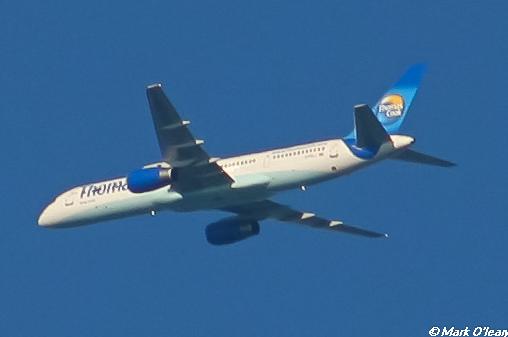How big plane is this?
Quick response, please. Large. What color is the logo on the tail of the plane?
Short answer required. Blue. Is this a passenger airplane?
Give a very brief answer. Yes. 